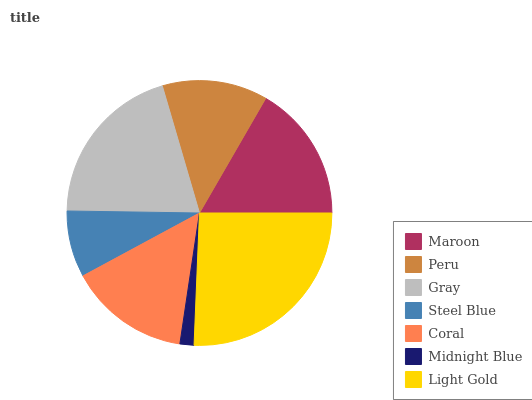Is Midnight Blue the minimum?
Answer yes or no. Yes. Is Light Gold the maximum?
Answer yes or no. Yes. Is Peru the minimum?
Answer yes or no. No. Is Peru the maximum?
Answer yes or no. No. Is Maroon greater than Peru?
Answer yes or no. Yes. Is Peru less than Maroon?
Answer yes or no. Yes. Is Peru greater than Maroon?
Answer yes or no. No. Is Maroon less than Peru?
Answer yes or no. No. Is Coral the high median?
Answer yes or no. Yes. Is Coral the low median?
Answer yes or no. Yes. Is Midnight Blue the high median?
Answer yes or no. No. Is Gray the low median?
Answer yes or no. No. 